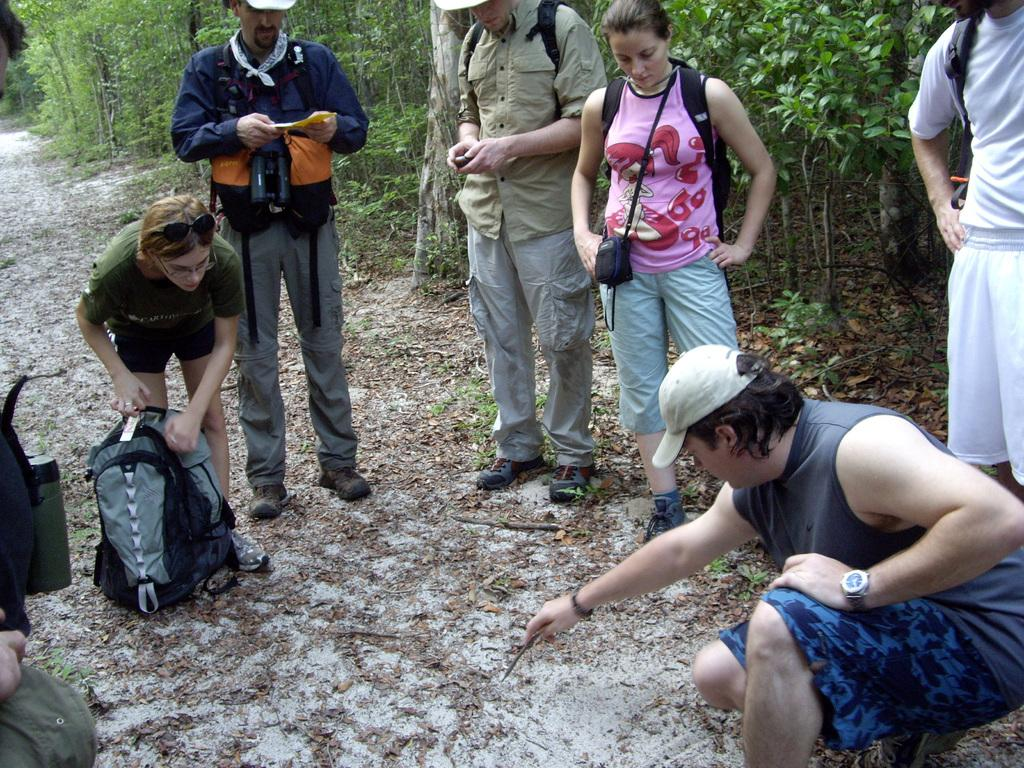Who or what can be seen in the image? There are people in the image. What are the people doing in the image? The people are standing with their luggage. What is the surface they are standing on? The surface they are standing on is visible. What can be seen in the background of the image? There are trees in the background of the image. What type of thunder can be heard in the image? There is no thunder present in the image, as it is a visual medium and does not include sound. 